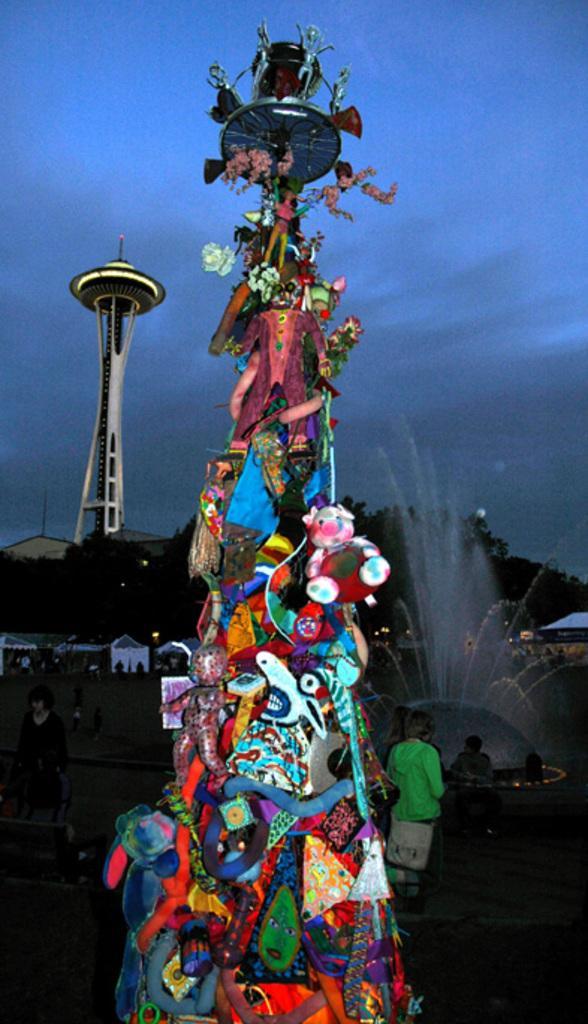Could you give a brief overview of what you see in this image? In this picture we can see few toys, few people and water, in the background we can see few trees, houses and a tower. 